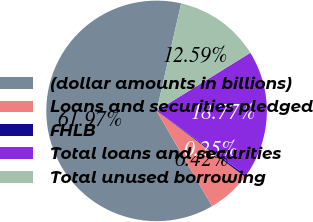<chart> <loc_0><loc_0><loc_500><loc_500><pie_chart><fcel>(dollar amounts in billions)<fcel>Loans and securities pledged<fcel>FHLB<fcel>Total loans and securities<fcel>Total unused borrowing<nl><fcel>61.96%<fcel>6.42%<fcel>0.25%<fcel>18.77%<fcel>12.59%<nl></chart> 